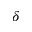<formula> <loc_0><loc_0><loc_500><loc_500>\delta</formula> 